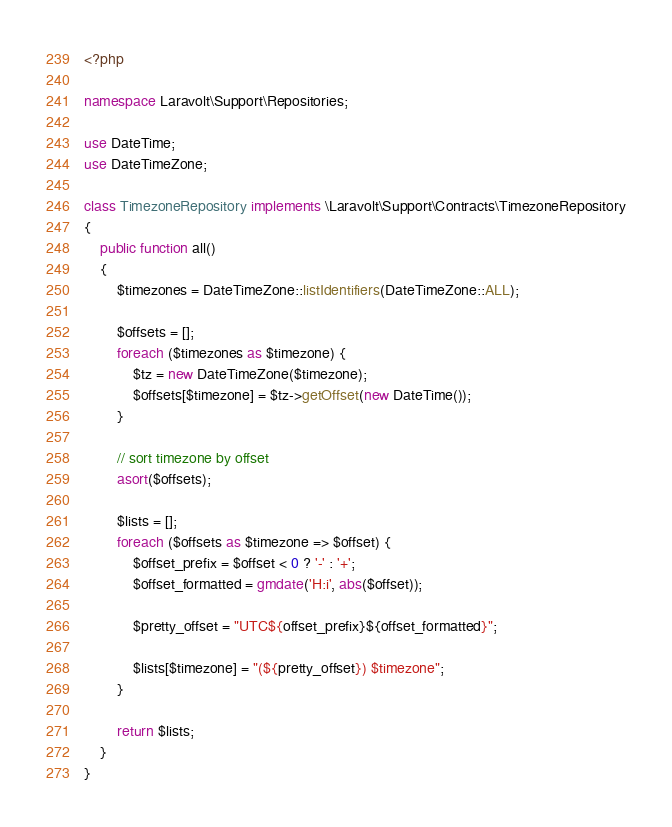Convert code to text. <code><loc_0><loc_0><loc_500><loc_500><_PHP_><?php

namespace Laravolt\Support\Repositories;

use DateTime;
use DateTimeZone;

class TimezoneRepository implements \Laravolt\Support\Contracts\TimezoneRepository
{
    public function all()
    {
        $timezones = DateTimeZone::listIdentifiers(DateTimeZone::ALL);

        $offsets = [];
        foreach ($timezones as $timezone) {
            $tz = new DateTimeZone($timezone);
            $offsets[$timezone] = $tz->getOffset(new DateTime());
        }

        // sort timezone by offset
        asort($offsets);

        $lists = [];
        foreach ($offsets as $timezone => $offset) {
            $offset_prefix = $offset < 0 ? '-' : '+';
            $offset_formatted = gmdate('H:i', abs($offset));

            $pretty_offset = "UTC${offset_prefix}${offset_formatted}";

            $lists[$timezone] = "(${pretty_offset}) $timezone";
        }

        return $lists;
    }
}
</code> 